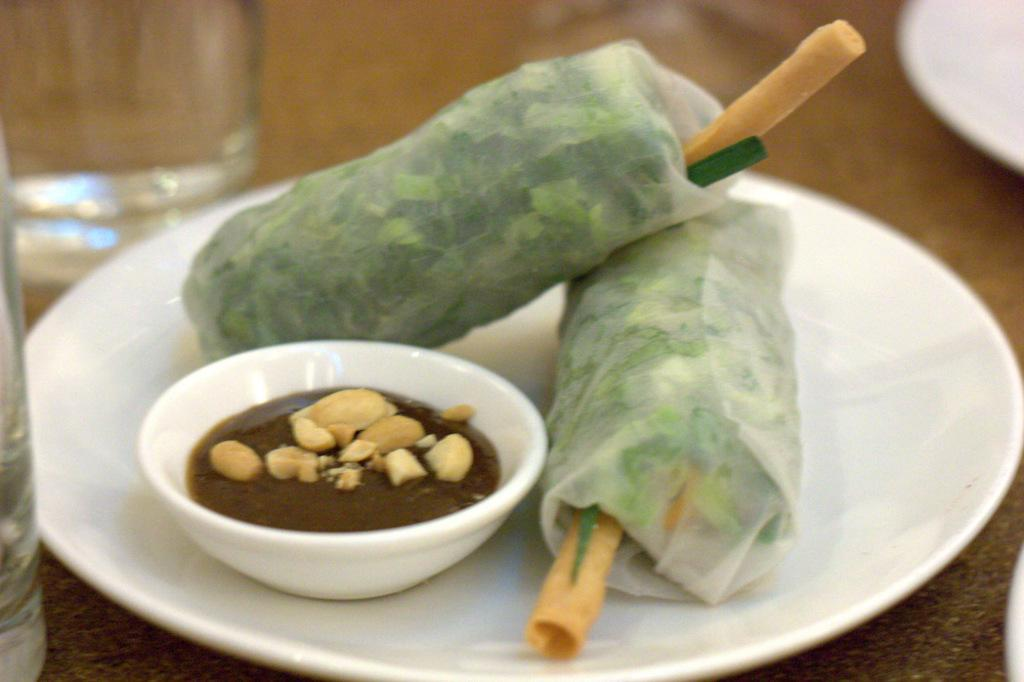What is on the plate that is visible in the image? There is a plate with food in the image. What else is on the table besides the plate? There is a bowl with food in the image, and it is also placed on the table. What type of tableware is present in the image? There are glasses in the image. Where are the glasses located in relation to the other items on the table? There is another plate beside the glasses in the image. What type of peace symbol can be seen on the plate? There is no peace symbol present on the plate; it contains food. 